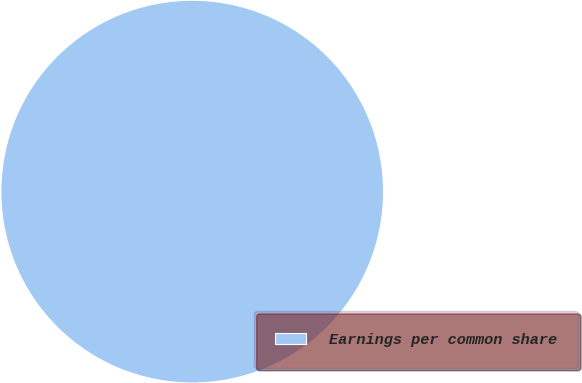Convert chart to OTSL. <chart><loc_0><loc_0><loc_500><loc_500><pie_chart><fcel>Earnings per common share<nl><fcel>100.0%<nl></chart> 